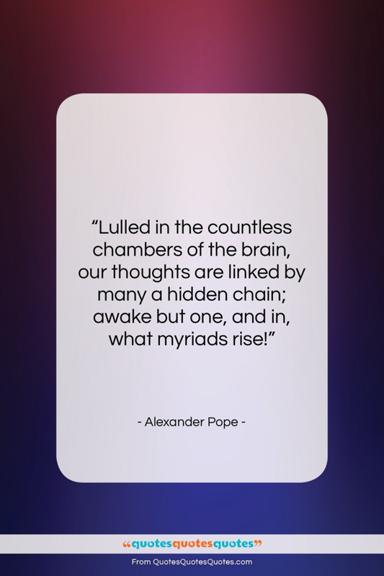How does the styling of the quote affect its impact? The quote is styled with a clean and modern serif font, which adds an air of sophistication and timelessness. The centered alignment on a white card framed by the gradient background gives the text a focal point, demanding the reader's attention. This presentation style enhances the impact by creating a visual 'pause' for reflection, which aligns well with the contemplative nature of Alexander Pope's words. 